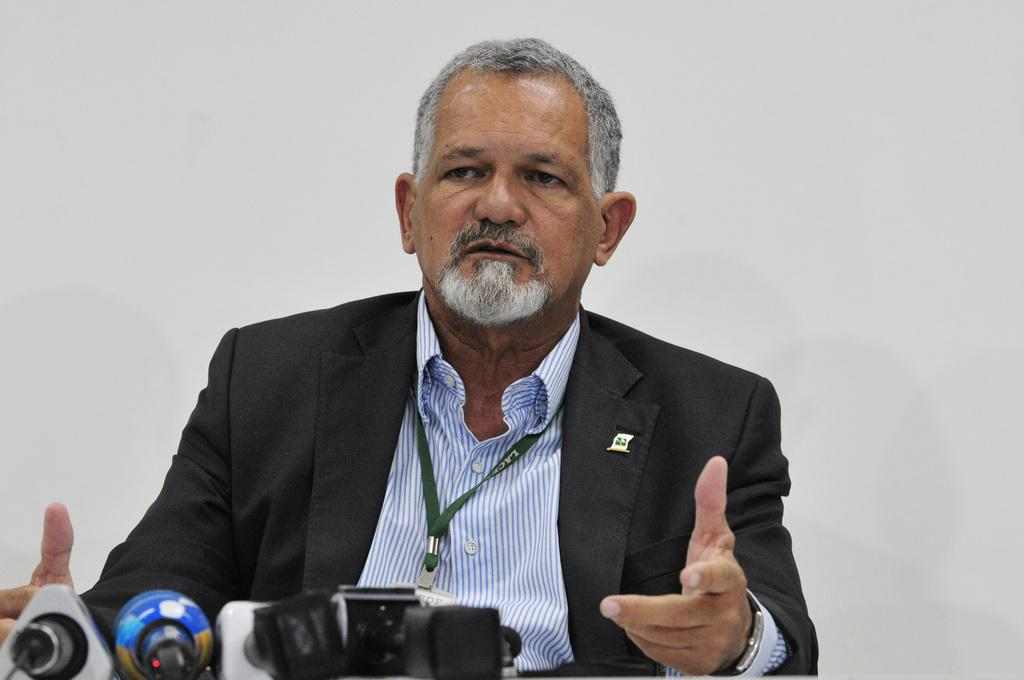Who is the main subject in the image? There is a man in the image. What is the man wearing? The man is wearing a suit. What is the man doing in the image? The man is sitting in front of microphones and talking. What can be seen on the man's clothing? The man is wearing an ID card. What is the color of the background in the image? The background of the image is white. How many apples are on the man's arm in the image? There are no apples present on the man's arm in the image. Is there a bed visible in the image? No, there is no bed visible in the image. 